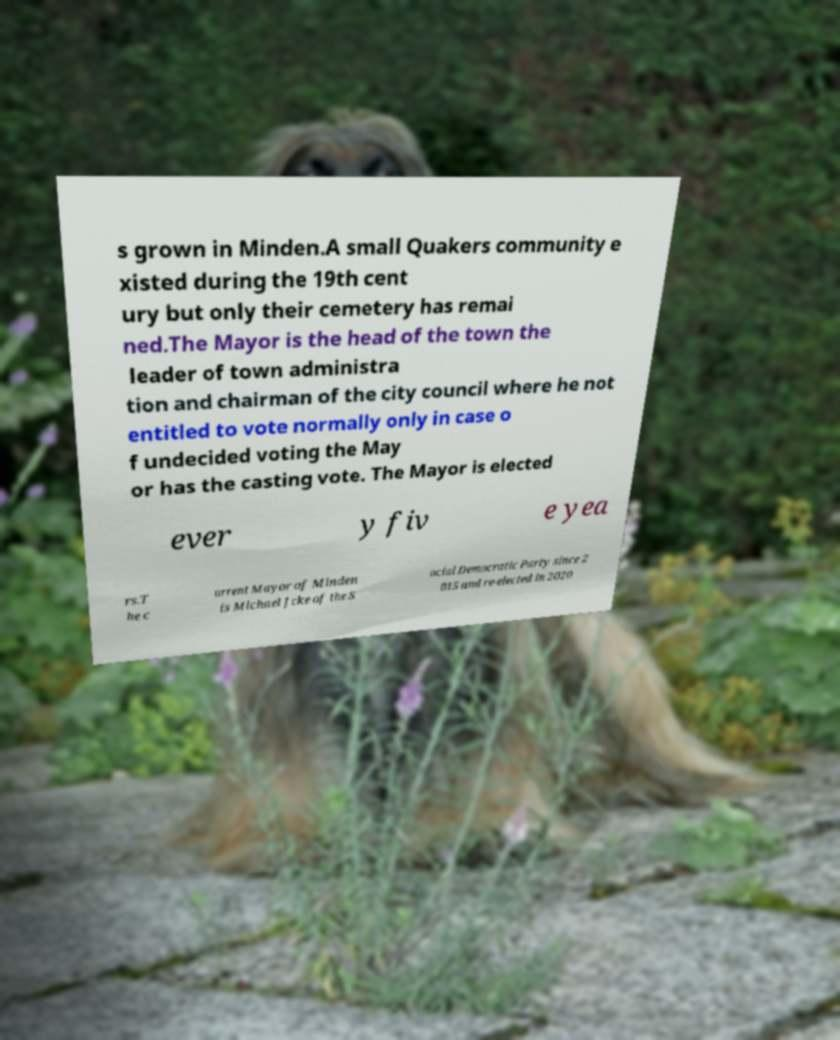Could you assist in decoding the text presented in this image and type it out clearly? s grown in Minden.A small Quakers community e xisted during the 19th cent ury but only their cemetery has remai ned.The Mayor is the head of the town the leader of town administra tion and chairman of the city council where he not entitled to vote normally only in case o f undecided voting the May or has the casting vote. The Mayor is elected ever y fiv e yea rs.T he c urrent Mayor of Minden is Michael Jcke of the S ocial Democratic Party since 2 015 and re-elected in 2020 